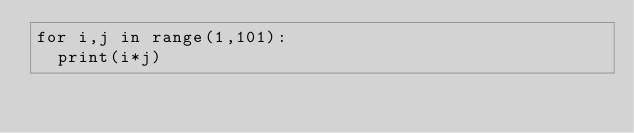Convert code to text. <code><loc_0><loc_0><loc_500><loc_500><_Python_>for i,j in range(1,101):
  print(i*j)</code> 